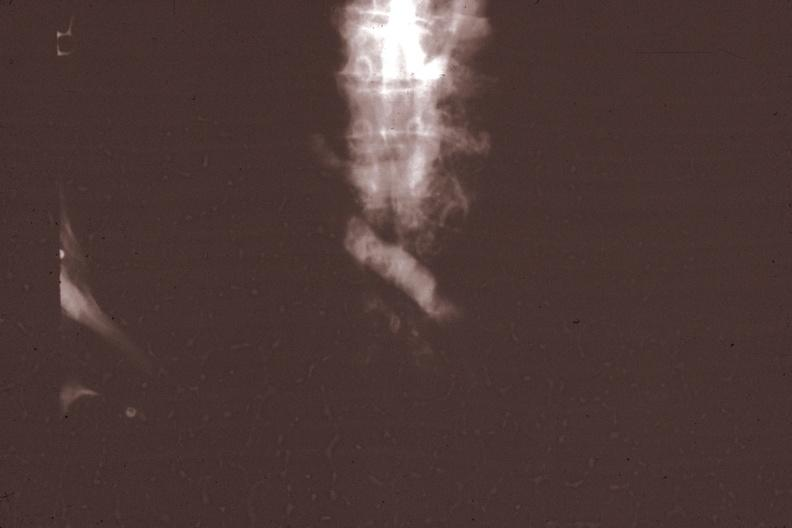s hematologic present?
Answer the question using a single word or phrase. Yes 